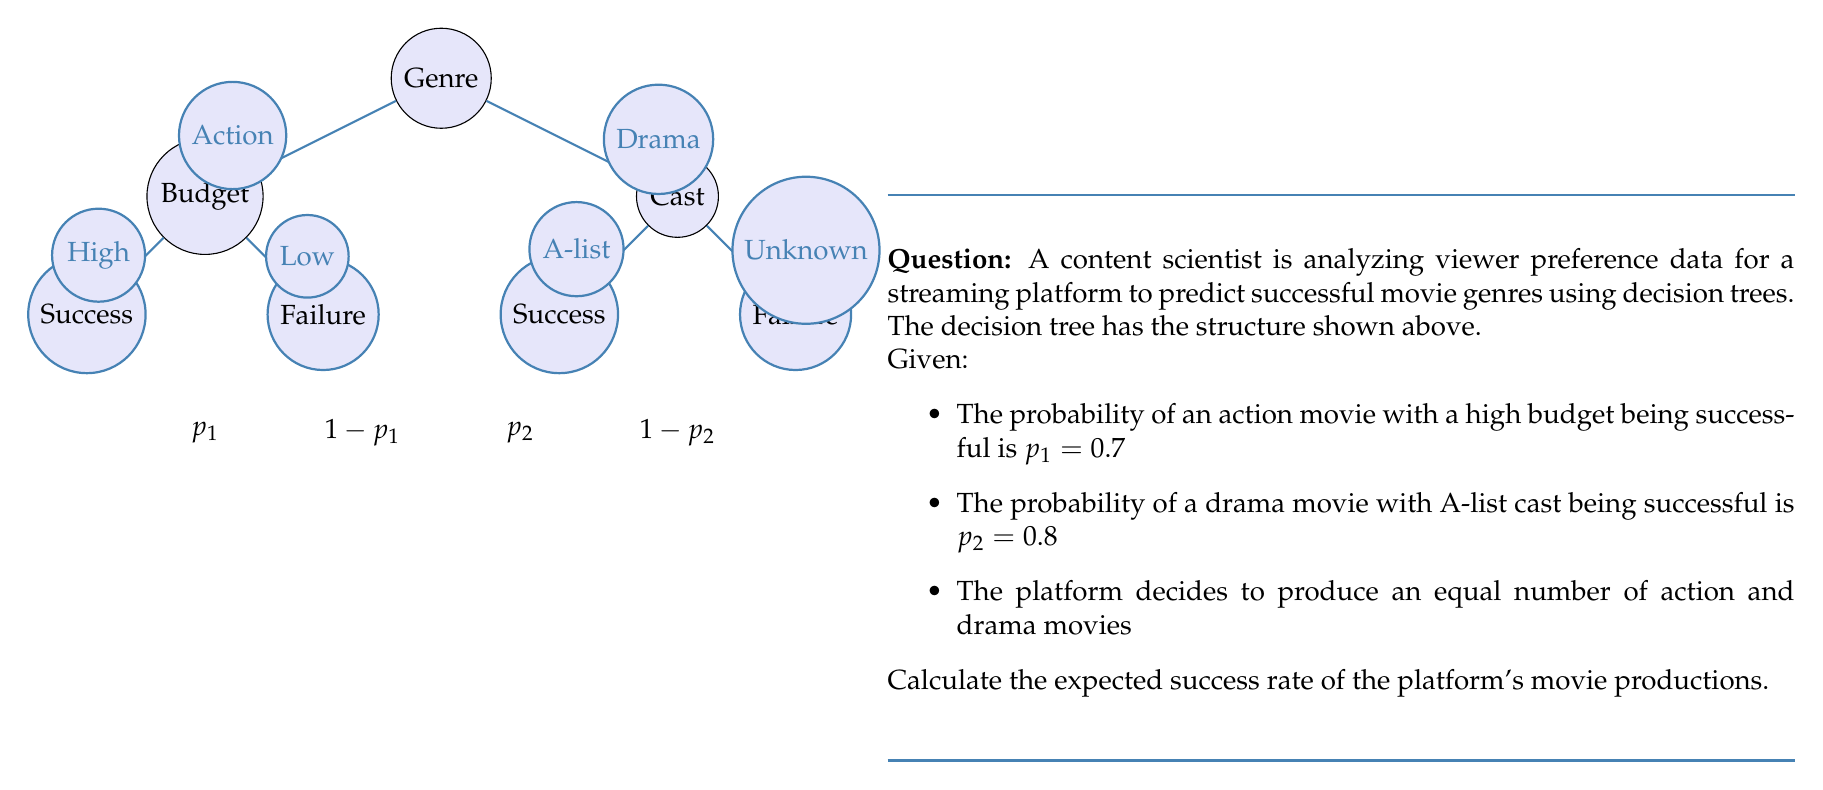Teach me how to tackle this problem. Let's approach this step-by-step:

1) First, we need to understand what the question is asking. We're looking for the overall expected success rate, considering both action and drama movies.

2) For action movies:
   - Success probability = $p_1 = 0.7$ (given)
   - Failure probability = $1 - p_1 = 0.3$

3) For drama movies:
   - Success probability = $p_2 = 0.8$ (given)
   - Failure probability = $1 - p_2 = 0.2$

4) The platform produces an equal number of action and drama movies. This means each type has a 50% share in the total production.

5) To calculate the overall expected success rate, we need to weigh each genre's success probability by its share in the total production:

   Expected Success Rate = (Share of Action × Success Rate of Action) + (Share of Drama × Success Rate of Drama)

6) Mathematically, this can be expressed as:

   $$\text{Expected Success Rate} = 0.5 \times p_1 + 0.5 \times p_2$$

7) Substituting the values:

   $$\text{Expected Success Rate} = 0.5 \times 0.7 + 0.5 \times 0.8$$

8) Calculating:

   $$\text{Expected Success Rate} = 0.35 + 0.4 = 0.75$$

Therefore, the expected success rate of the platform's movie productions is 0.75 or 75%.
Answer: 0.75 